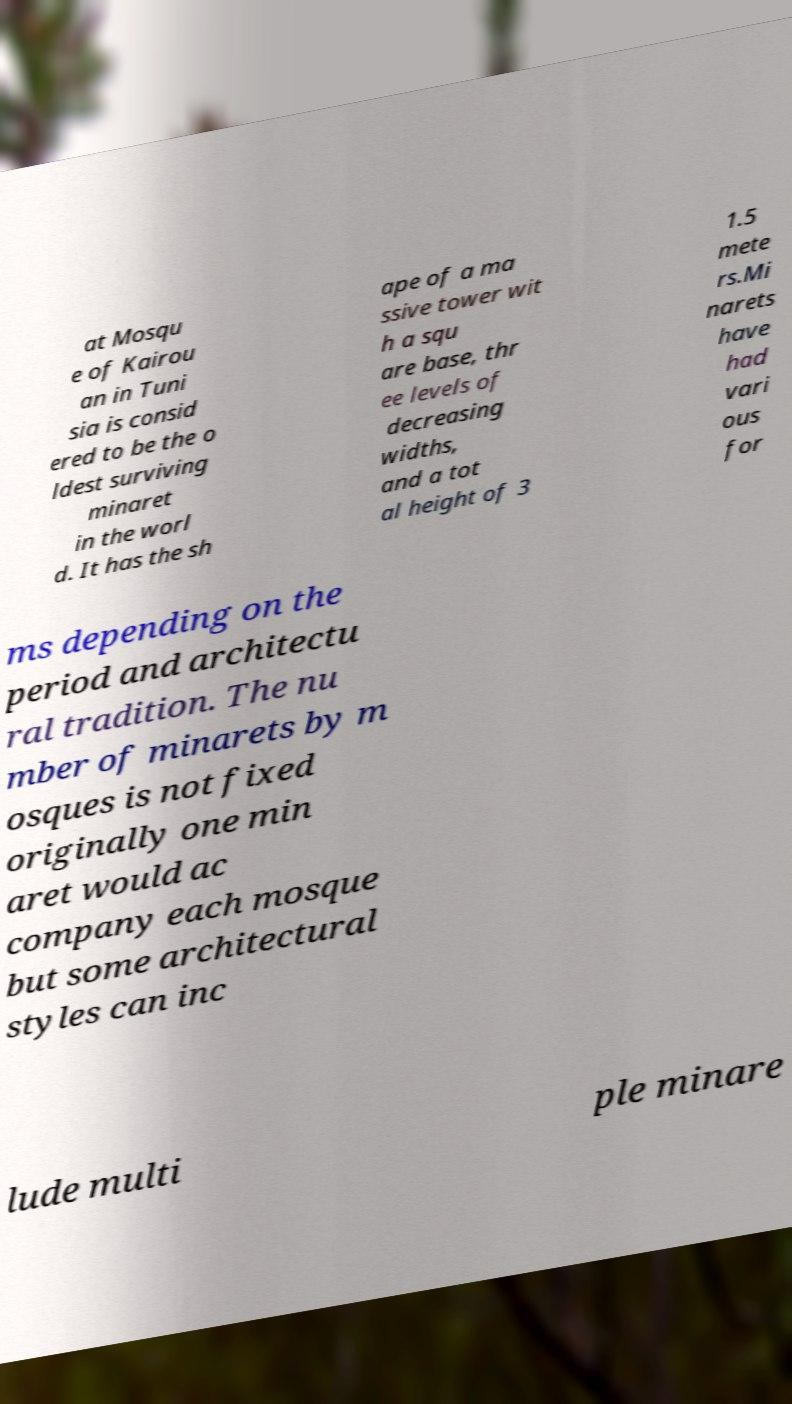Could you assist in decoding the text presented in this image and type it out clearly? at Mosqu e of Kairou an in Tuni sia is consid ered to be the o ldest surviving minaret in the worl d. It has the sh ape of a ma ssive tower wit h a squ are base, thr ee levels of decreasing widths, and a tot al height of 3 1.5 mete rs.Mi narets have had vari ous for ms depending on the period and architectu ral tradition. The nu mber of minarets by m osques is not fixed originally one min aret would ac company each mosque but some architectural styles can inc lude multi ple minare 